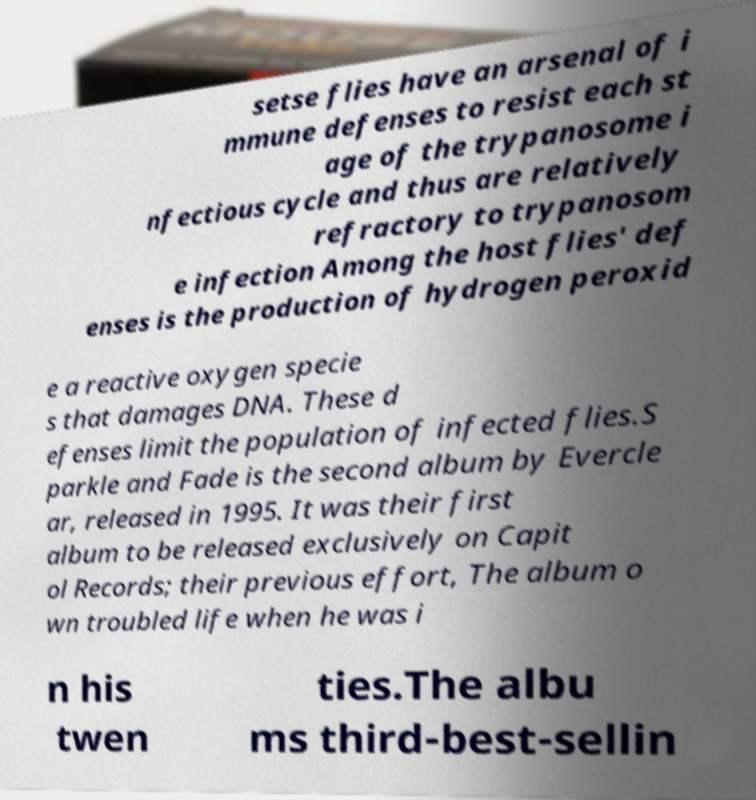Can you accurately transcribe the text from the provided image for me? setse flies have an arsenal of i mmune defenses to resist each st age of the trypanosome i nfectious cycle and thus are relatively refractory to trypanosom e infection Among the host flies' def enses is the production of hydrogen peroxid e a reactive oxygen specie s that damages DNA. These d efenses limit the population of infected flies.S parkle and Fade is the second album by Evercle ar, released in 1995. It was their first album to be released exclusively on Capit ol Records; their previous effort, The album o wn troubled life when he was i n his twen ties.The albu ms third-best-sellin 